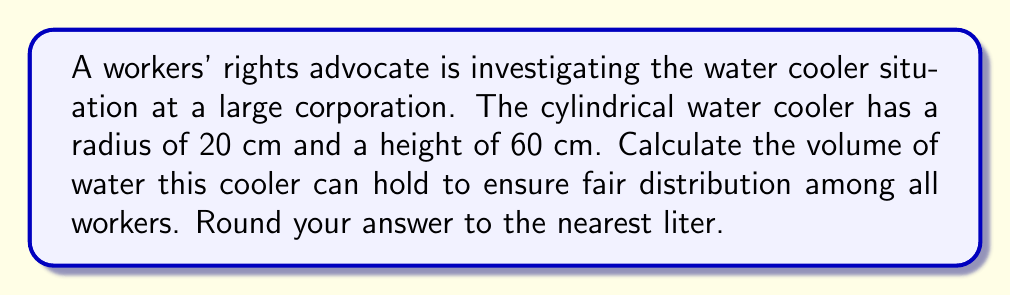Give your solution to this math problem. To calculate the volume of a cylindrical water cooler, we need to use the formula for the volume of a cylinder:

$$V = \pi r^2 h$$

Where:
$V$ = volume
$r$ = radius of the base
$h$ = height of the cylinder

Given:
$r = 20$ cm
$h = 60$ cm

Let's substitute these values into the formula:

$$V = \pi (20\text{ cm})^2 (60\text{ cm})$$

Simplifying:
$$V = \pi (400\text{ cm}^2) (60\text{ cm})$$
$$V = 24000\pi\text{ cm}^3$$

Now, let's calculate this value:
$$V \approx 75398.22\text{ cm}^3$$

To convert cubic centimeters to liters, we divide by 1000:

$$75398.22\text{ cm}^3 \div 1000 = 75.39822\text{ L}$$

Rounding to the nearest liter:

$$75.39822\text{ L} \approx 75\text{ L}$$

Therefore, the water cooler can hold approximately 75 liters of water.
Answer: 75 L 